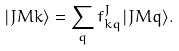<formula> <loc_0><loc_0><loc_500><loc_500>| J M k \rangle = \sum _ { q } f ^ { J } _ { k q } | J M q \rangle .</formula> 